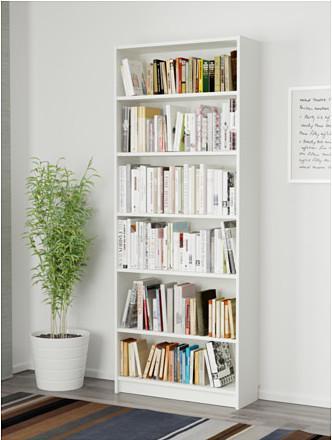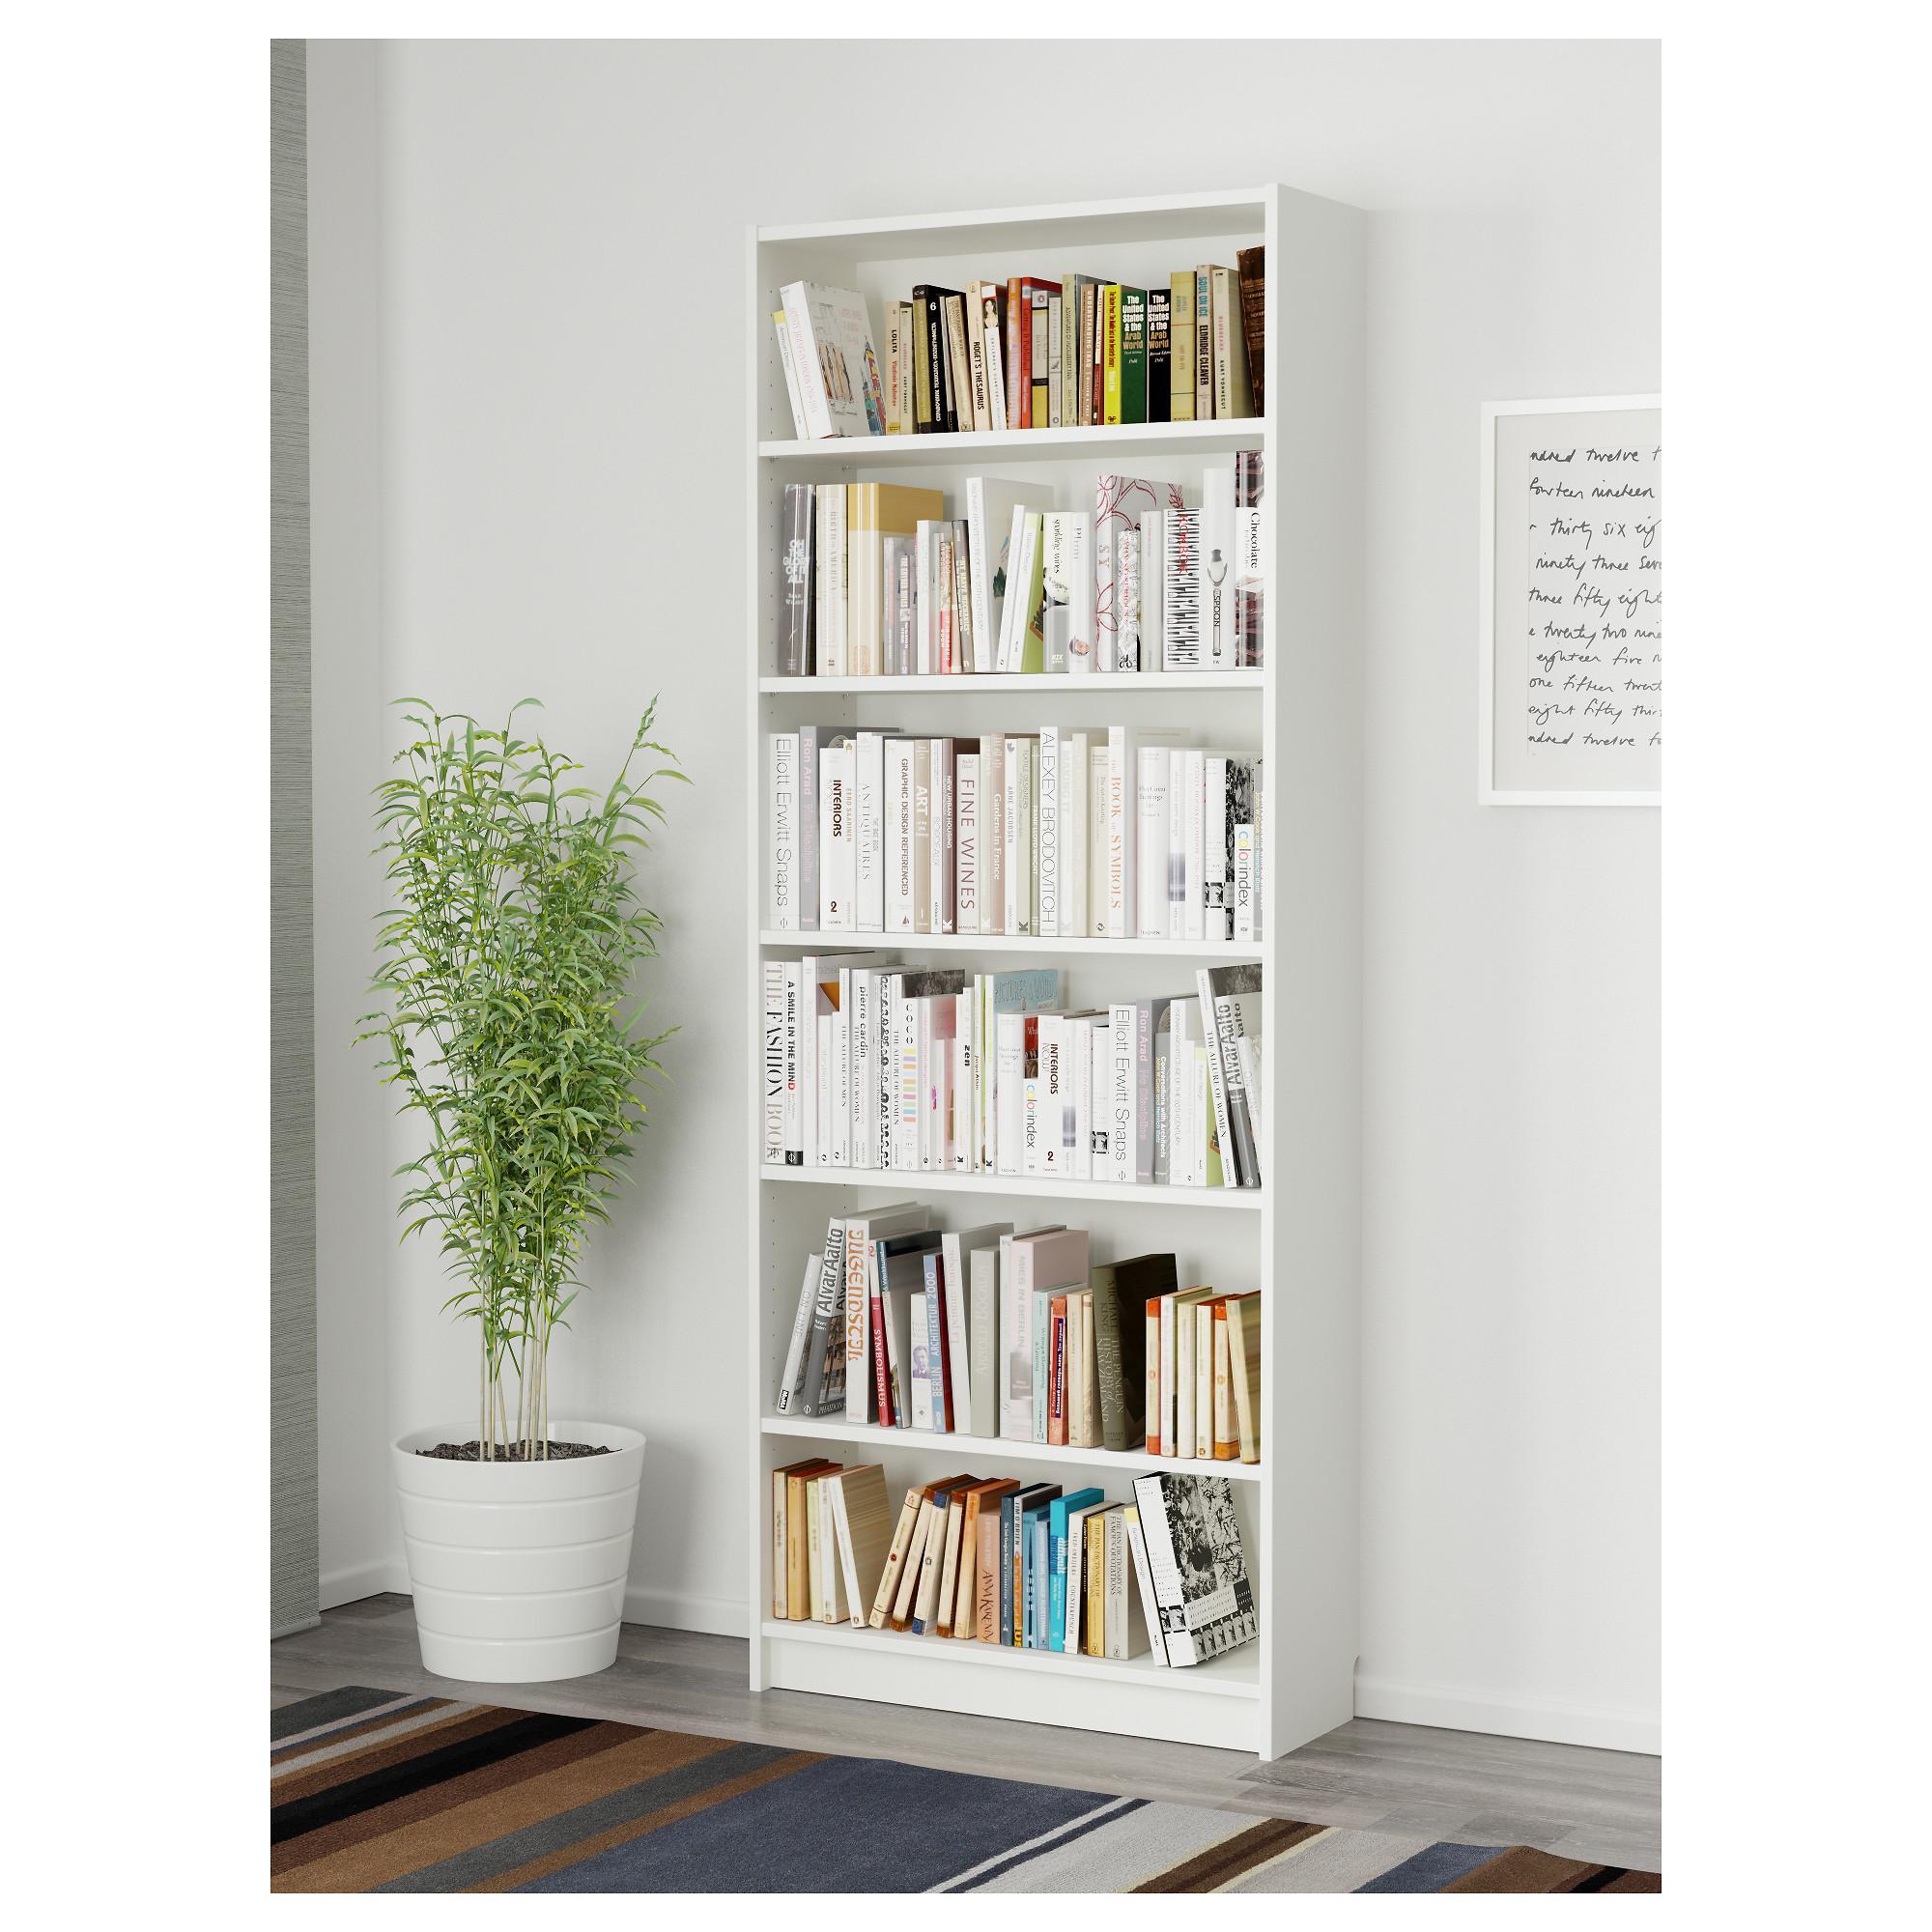The first image is the image on the left, the second image is the image on the right. For the images displayed, is the sentence "The left image contains a bookshelf that is not white." factually correct? Answer yes or no. No. 